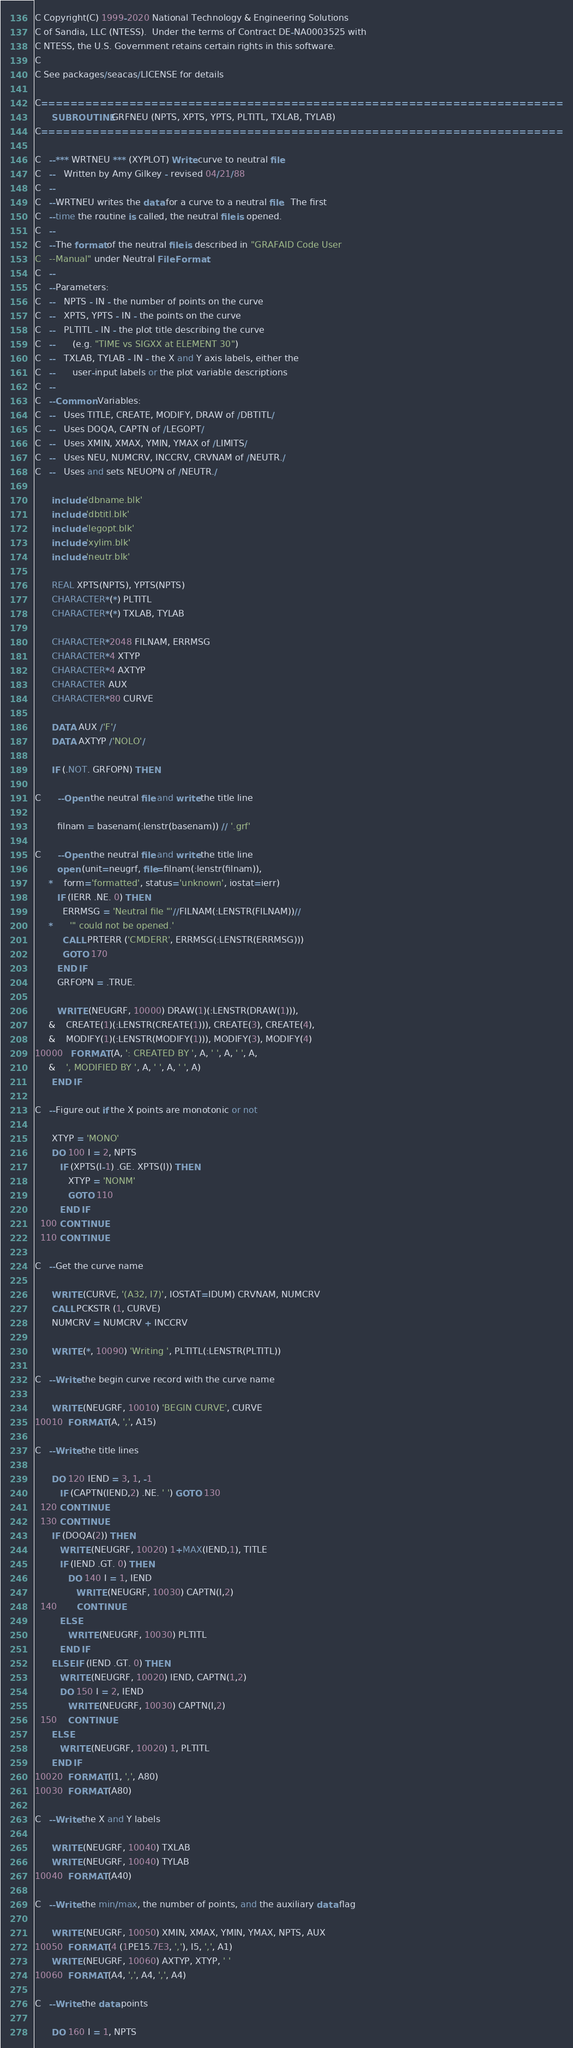<code> <loc_0><loc_0><loc_500><loc_500><_FORTRAN_>C Copyright(C) 1999-2020 National Technology & Engineering Solutions
C of Sandia, LLC (NTESS).  Under the terms of Contract DE-NA0003525 with
C NTESS, the U.S. Government retains certain rights in this software.
C
C See packages/seacas/LICENSE for details

C=======================================================================
      SUBROUTINE GRFNEU (NPTS, XPTS, YPTS, PLTITL, TXLAB, TYLAB)
C=======================================================================

C   --*** WRTNEU *** (XYPLOT) Write curve to neutral file
C   --   Written by Amy Gilkey - revised 04/21/88
C   --
C   --WRTNEU writes the data for a curve to a neutral file.  The first
C   --time the routine is called, the neutral file is opened.
C   --
C   --The format of the neutral file is described in "GRAFAID Code User
C   --Manual" under Neutral File Format.
C   --
C   --Parameters:
C   --   NPTS - IN - the number of points on the curve
C   --   XPTS, YPTS - IN - the points on the curve
C   --   PLTITL - IN - the plot title describing the curve
C   --      (e.g. "TIME vs SIGXX at ELEMENT 30")
C   --   TXLAB, TYLAB - IN - the X and Y axis labels, either the
C   --      user-input labels or the plot variable descriptions
C   --
C   --Common Variables:
C   --   Uses TITLE, CREATE, MODIFY, DRAW of /DBTITL/
C   --   Uses DOQA, CAPTN of /LEGOPT/
C   --   Uses XMIN, XMAX, YMIN, YMAX of /LIMITS/
C   --   Uses NEU, NUMCRV, INCCRV, CRVNAM of /NEUTR./
C   --   Uses and sets NEUOPN of /NEUTR./

      include 'dbname.blk'
      include 'dbtitl.blk'
      include 'legopt.blk'
      include 'xylim.blk'
      include 'neutr.blk'

      REAL XPTS(NPTS), YPTS(NPTS)
      CHARACTER*(*) PLTITL
      CHARACTER*(*) TXLAB, TYLAB

      CHARACTER*2048 FILNAM, ERRMSG
      CHARACTER*4 XTYP
      CHARACTER*4 AXTYP
      CHARACTER AUX
      CHARACTER*80 CURVE

      DATA AUX /'F'/
      DATA AXTYP /'NOLO'/

      IF (.NOT. GRFOPN) THEN

C      --Open the neutral file and write the title line

        filnam = basenam(:lenstr(basenam)) // '.grf'

C      --Open the neutral file and write the title line
        open (unit=neugrf, file=filnam(:lenstr(filnam)),
     *    form='formatted', status='unknown', iostat=ierr)
        IF (IERR .NE. 0) THEN
          ERRMSG = 'Neutral file "'//FILNAM(:LENSTR(FILNAM))//
     *      '" could not be opened.'
          CALL PRTERR ('CMDERR', ERRMSG(:LENSTR(ERRMSG)))
          GOTO 170
        END IF
        GRFOPN = .TRUE.

        WRITE (NEUGRF, 10000) DRAW(1)(:LENSTR(DRAW(1))),
     &    CREATE(1)(:LENSTR(CREATE(1))), CREATE(3), CREATE(4),
     &    MODIFY(1)(:LENSTR(MODIFY(1))), MODIFY(3), MODIFY(4)
10000   FORMAT (A, ': CREATED BY ', A, ' ', A, ' ', A,
     &    ', MODIFIED BY ', A, ' ', A, ' ', A)
      END IF

C   --Figure out if the X points are monotonic or not

      XTYP = 'MONO'
      DO 100 I = 2, NPTS
         IF (XPTS(I-1) .GE. XPTS(I)) THEN
            XTYP = 'NONM'
            GOTO 110
         END IF
  100 CONTINUE
  110 CONTINUE

C   --Get the curve name

      WRITE (CURVE, '(A32, I7)', IOSTAT=IDUM) CRVNAM, NUMCRV
      CALL PCKSTR (1, CURVE)
      NUMCRV = NUMCRV + INCCRV

      WRITE (*, 10090) 'Writing ', PLTITL(:LENSTR(PLTITL))

C   --Write the begin curve record with the curve name

      WRITE (NEUGRF, 10010) 'BEGIN CURVE', CURVE
10010  FORMAT (A, ',', A15)

C   --Write the title lines

      DO 120 IEND = 3, 1, -1
         IF (CAPTN(IEND,2) .NE. ' ') GOTO 130
  120 CONTINUE
  130 CONTINUE
      IF (DOQA(2)) THEN
         WRITE (NEUGRF, 10020) 1+MAX(IEND,1), TITLE
         IF (IEND .GT. 0) THEN
            DO 140 I = 1, IEND
               WRITE (NEUGRF, 10030) CAPTN(I,2)
  140       CONTINUE
         ELSE
            WRITE (NEUGRF, 10030) PLTITL
         END IF
      ELSE IF (IEND .GT. 0) THEN
         WRITE (NEUGRF, 10020) IEND, CAPTN(1,2)
         DO 150 I = 2, IEND
            WRITE (NEUGRF, 10030) CAPTN(I,2)
  150    CONTINUE
      ELSE
         WRITE (NEUGRF, 10020) 1, PLTITL
      END IF
10020  FORMAT (I1, ',', A80)
10030  FORMAT (A80)

C   --Write the X and Y labels

      WRITE (NEUGRF, 10040) TXLAB
      WRITE (NEUGRF, 10040) TYLAB
10040  FORMAT (A40)

C   --Write the min/max, the number of points, and the auxiliary data flag

      WRITE (NEUGRF, 10050) XMIN, XMAX, YMIN, YMAX, NPTS, AUX
10050  FORMAT (4 (1PE15.7E3, ','), I5, ',', A1)
      WRITE (NEUGRF, 10060) AXTYP, XTYP, ' '
10060  FORMAT (A4, ',', A4, ',', A4)

C   --Write the data points

      DO 160 I = 1, NPTS</code> 